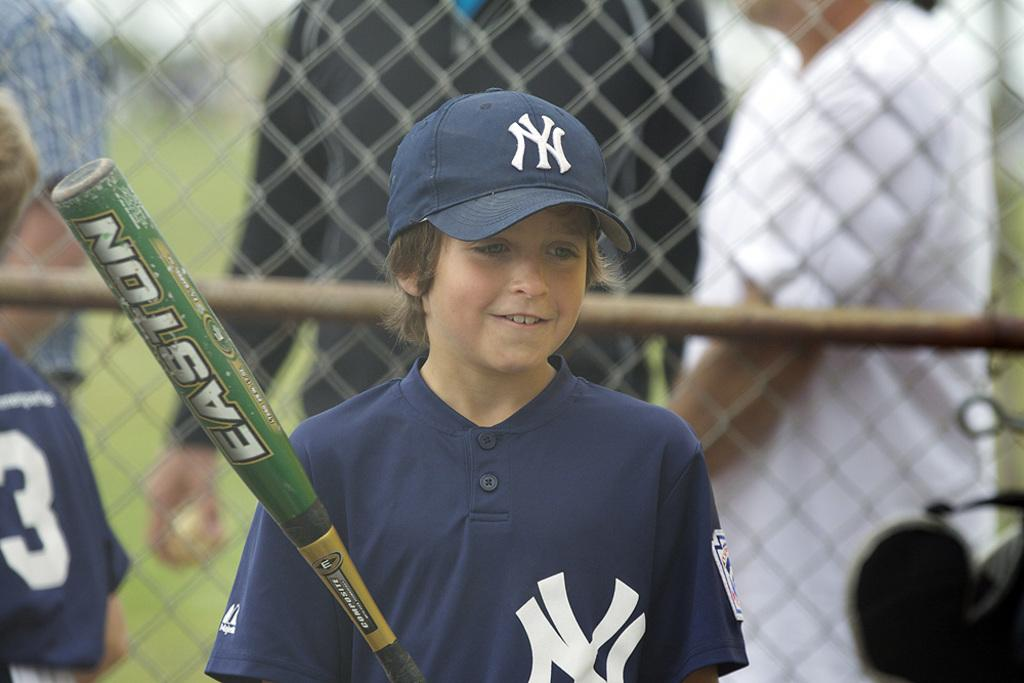Provide a one-sentence caption for the provided image. A kid is holding a Easton bat while wearing a blue cap. 